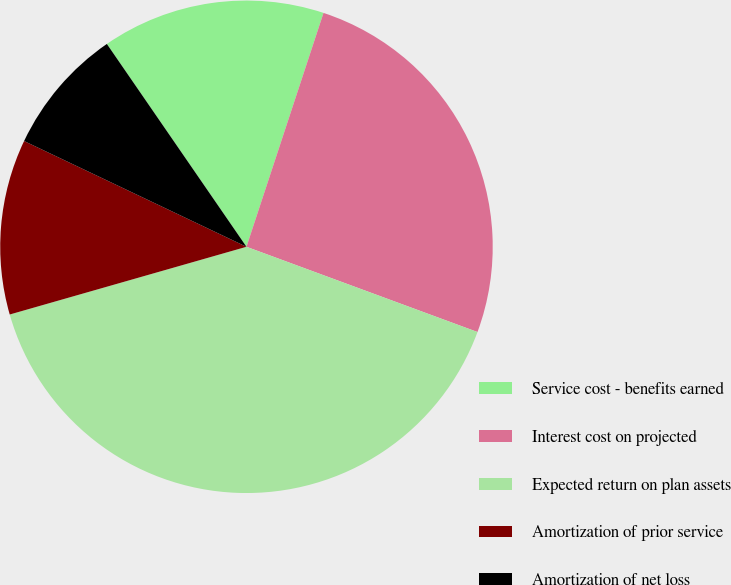Convert chart. <chart><loc_0><loc_0><loc_500><loc_500><pie_chart><fcel>Service cost - benefits earned<fcel>Interest cost on projected<fcel>Expected return on plan assets<fcel>Amortization of prior service<fcel>Amortization of net loss<nl><fcel>14.66%<fcel>25.56%<fcel>39.94%<fcel>11.5%<fcel>8.34%<nl></chart> 